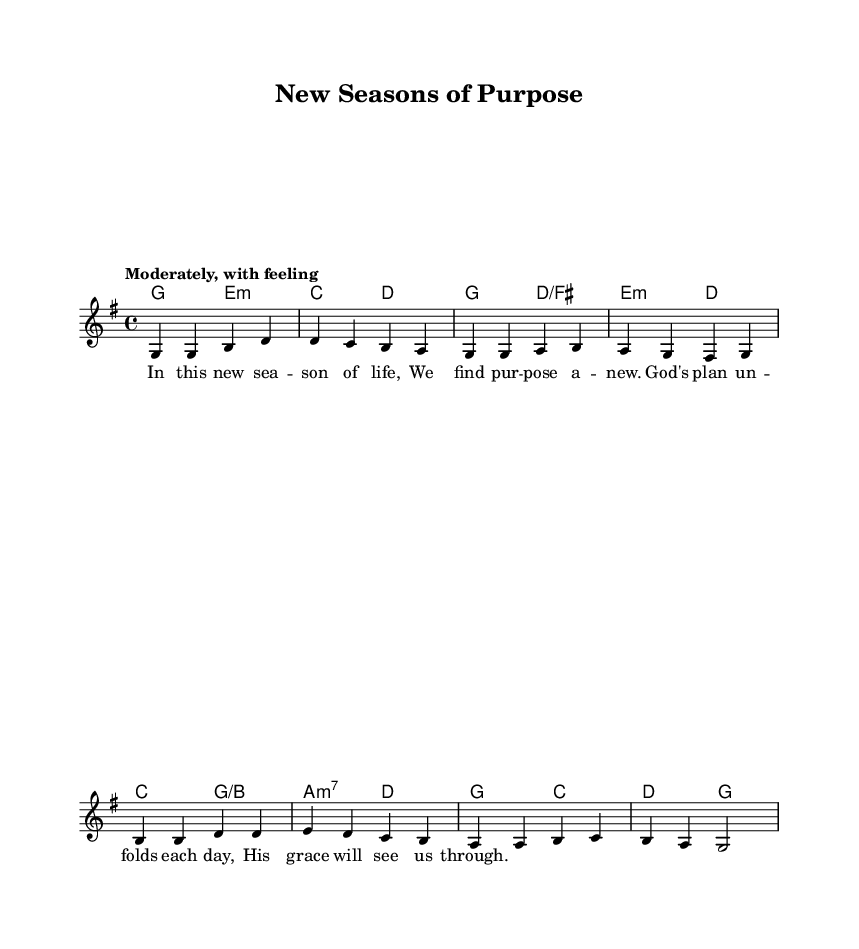What is the key signature of this music? The key signature is G major, indicated by one sharp (F#) at the beginning of the staff.
Answer: G major What is the time signature of this music? The time signature is 4/4, which means there are four beats in each measure and the quarter note gets one beat.
Answer: 4/4 What is the tempo marking for this piece? The tempo marking states "Moderately, with feeling," indicating the intended speed and emotional expression of the music.
Answer: Moderately, with feeling What is the first lyric of the verse? The first line of the verse is "In this new sea -- son of life," which is presented directly under the corresponding notes in the melody.
Answer: In this new sea -- son of life How many measures are in the melody section? Counting the number of vertical lines (bar lines) in the melody, there are a total of eight measures in this section of the score.
Answer: Eight What harmony is associated with the first measure of the melody? The first measure of the melody has a G major chord, which corresponds to the notes played in that measure.
Answer: G major What is the last line of the verse? The last line of the verse concludes with "His grace will see us through," representing the final message of hope in this piece.
Answer: His grace will see us through 